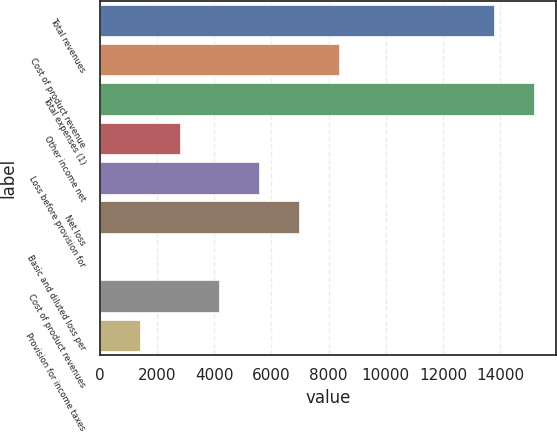Convert chart to OTSL. <chart><loc_0><loc_0><loc_500><loc_500><bar_chart><fcel>Total revenues<fcel>Cost of product revenue<fcel>Total expenses (1)<fcel>Other income net<fcel>Loss before provision for<fcel>Net loss<fcel>Basic and diluted loss per<fcel>Cost of product revenues<fcel>Provision for income taxes<nl><fcel>13796<fcel>8364.08<fcel>15190<fcel>2788.12<fcel>5576.1<fcel>6970.09<fcel>0.14<fcel>4182.11<fcel>1394.13<nl></chart> 